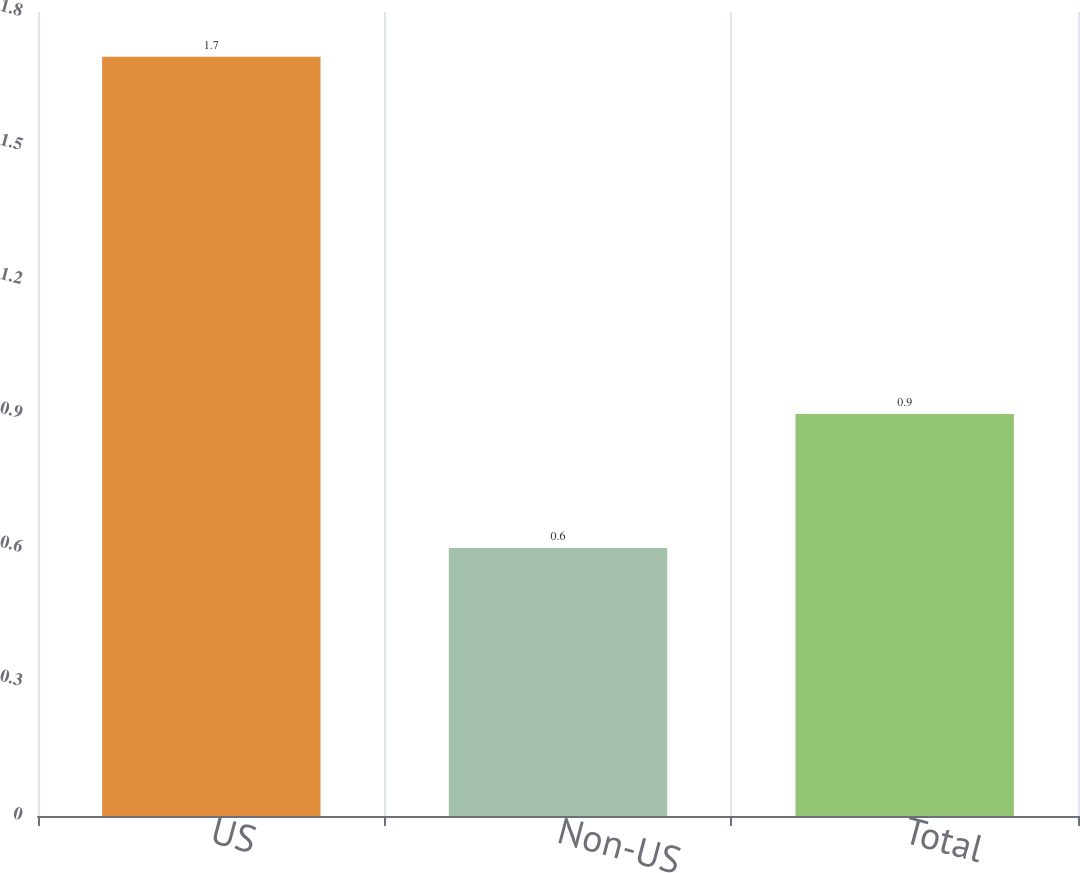<chart> <loc_0><loc_0><loc_500><loc_500><bar_chart><fcel>US<fcel>Non-US<fcel>Total<nl><fcel>1.7<fcel>0.6<fcel>0.9<nl></chart> 